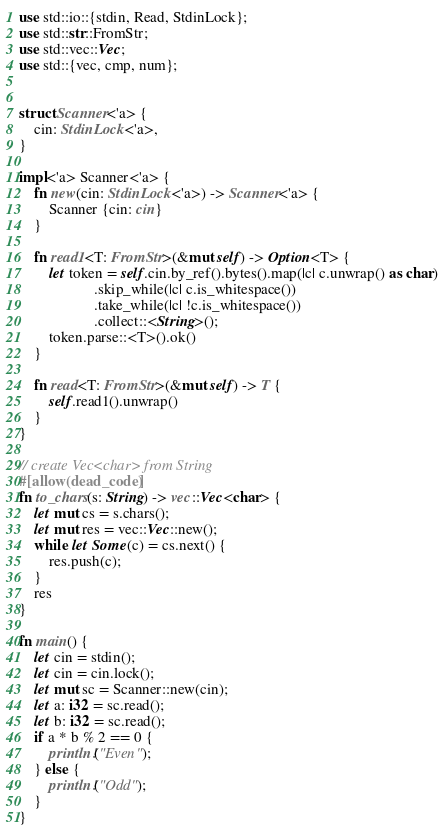Convert code to text. <code><loc_0><loc_0><loc_500><loc_500><_Rust_>use std::io::{stdin, Read, StdinLock};
use std::str::FromStr;
use std::vec::Vec;
use std::{vec, cmp, num};


struct Scanner<'a> {
    cin: StdinLock<'a>,
}

impl<'a> Scanner<'a> {
    fn new(cin: StdinLock<'a>) -> Scanner<'a> {
        Scanner {cin: cin}
    }

    fn read1<T: FromStr>(&mut self) -> Option<T> {
        let token = self.cin.by_ref().bytes().map(|c| c.unwrap() as char)
                    .skip_while(|c| c.is_whitespace())
                    .take_while(|c| !c.is_whitespace())
                    .collect::<String>();
        token.parse::<T>().ok()
    }

    fn read<T: FromStr>(&mut self) -> T {
        self.read1().unwrap()
    }
}

// create Vec<char> from String
#[allow(dead_code)]
fn to_chars(s: String) -> vec::Vec<char> {
    let mut cs = s.chars();
    let mut res = vec::Vec::new();
    while let Some(c) = cs.next() {
        res.push(c);
    }
    res
}

fn main() {
    let cin = stdin();
    let cin = cin.lock();
    let mut sc = Scanner::new(cin);
    let a: i32 = sc.read();
    let b: i32 = sc.read();
    if a * b % 2 == 0 {
        println!("Even");
    } else {
        println!("Odd");
    }
}</code> 